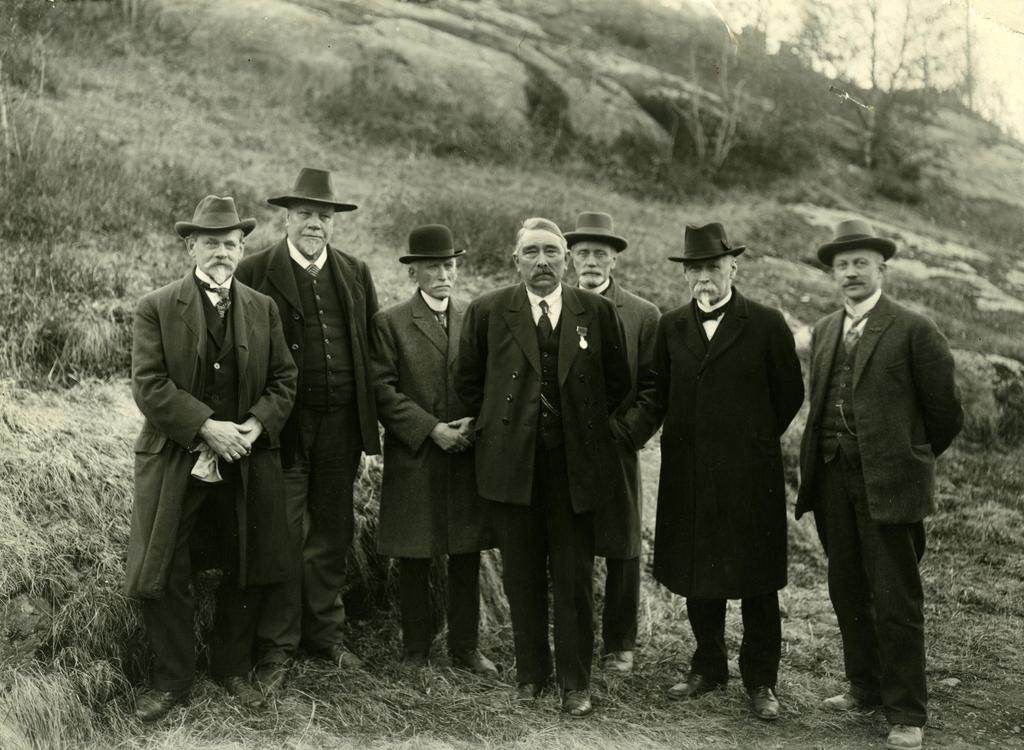What can be seen in the image? There are people standing in the image. What are the people wearing on their heads? The people are wearing hats. What type of natural environment is visible in the background of the image? There is grass and trees in the background of the image. What brand of toothpaste do the people in the image use? There is no information about toothpaste or personal hygiene products in the image. 